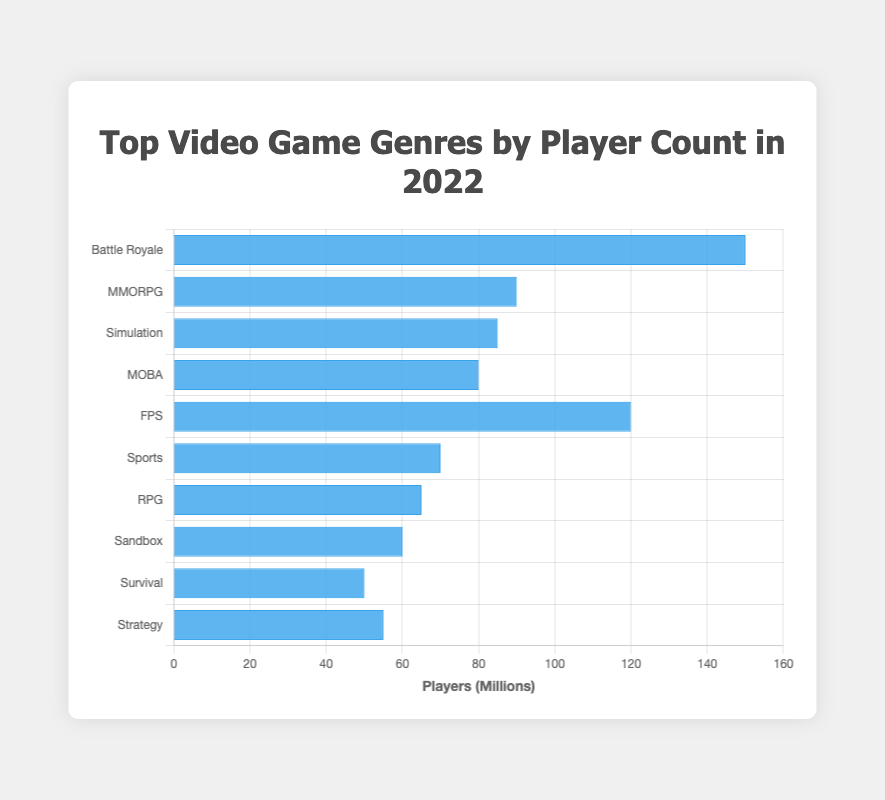Which genre has the highest player count in 2022? By looking at the height of the bars, the "Battle Royale" genre has the tallest bar, indicating the highest player count.
Answer: Battle Royale What is the player count for Simulation games? Looking at the bar corresponding to the "Simulation" genre, it reaches up to 85 on the x-axis, representing 85 million players.
Answer: 85 million Which genre has more players: MOBA or FPS? By comparing the height of the "MOBA" and "FPS" bars, "FPS" is taller with 120 million, while "MOBA" has 80 million.
Answer: FPS How many more players does Battle Royale have than Sports? The "Battle Royale" genre has 150 million players, and the "Sports" genre has 70 million players. The difference is 150 - 70 = 80 million.
Answer: 80 million What is the total player count for MMORPGs and RPGs combined? The "MMORPG" genre has 90 million players and the "RPG" genre has 65 million players. Summing them up gives 90 + 65 = 155 million.
Answer: 155 million Which genre has the lowest player count in 2022? The "Survival" genre has the shortest bar, indicating the lowest player count of 50 million.
Answer: Survival What is the average player count for all listed genres? Sum the player counts: 150 + 90 + 85 + 80 + 120 + 70 + 65 + 60 + 50 + 55 = 825 million. There are 10 genres, so the average is 825 / 10 = 82.5 million.
Answer: 82.5 million Are there more players in the Strategy genre or the Sandbox genre? By comparing the bars, the "Strategy" genre has 55 million players and the "Sandbox" genre has 60 million players. The "Sandbox" genre has more players.
Answer: Sandbox How many genres have a player count greater than 80 million? Looking at the chart, the genres with counts greater than 80 million are "Battle Royale" (150), "FPS" (120), "MMORPG" (90), and "Simulation" (85). There are 4 genres in total.
Answer: 4 What is the difference in player count between the top two genres? The top two genres are "Battle Royale" with 150 million and "FPS" with 120 million players. The difference is 150 - 120 = 30 million.
Answer: 30 million 